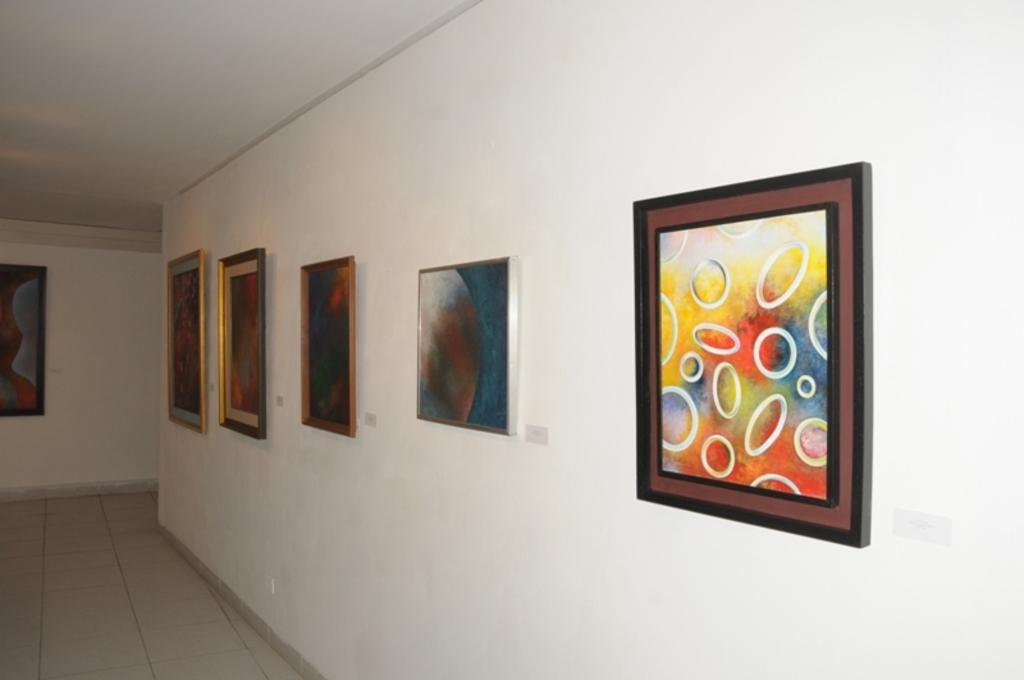What is hanging on the wall in the image? There are frames on the wall in the image. What type of hill can be seen in the background of the image? There is no hill visible in the image; it only shows frames on the wall. What kind of loaf is being prepared in the scene? There is no scene or loaf present in the image; it only shows frames on the wall. 